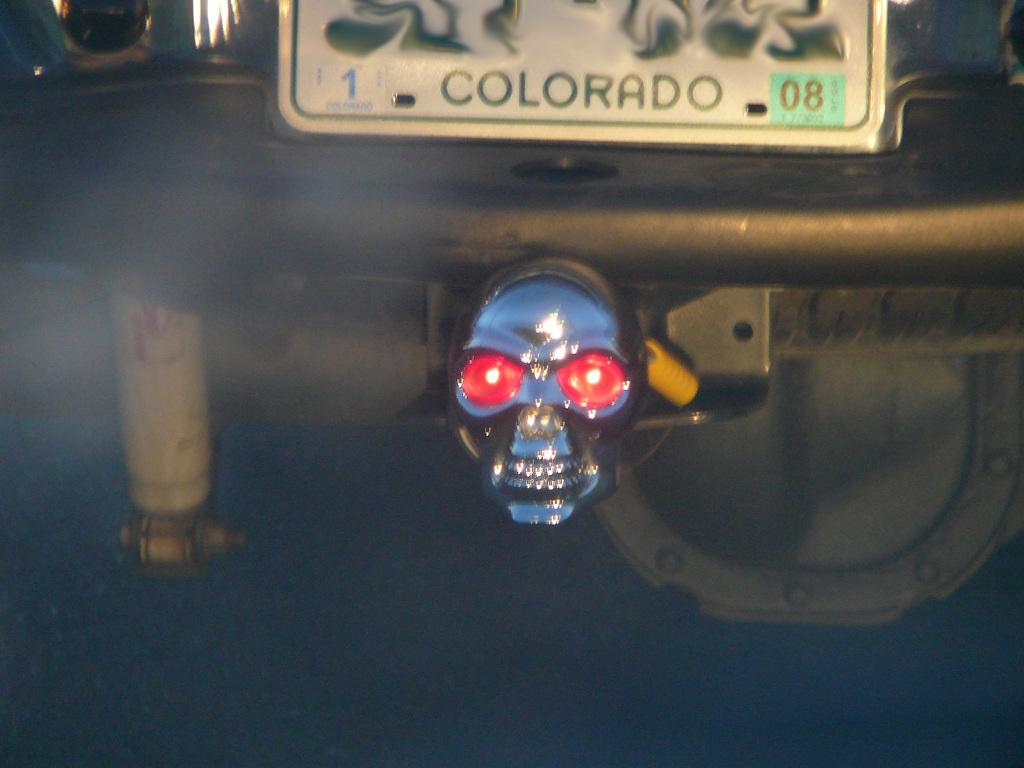What is the main subject of the image? The main subject of the image is a car. Can you describe any specific details about the car? The number plate of the car is visible in the image. From which angle is the car being viewed? The view of the car is from the backside. What type of animal can be seen sitting on the roof of the car in the image? There is no animal present on the roof of the car in the image. What idea does the car represent in the image? The image does not convey any specific ideas or concepts related to the car. 